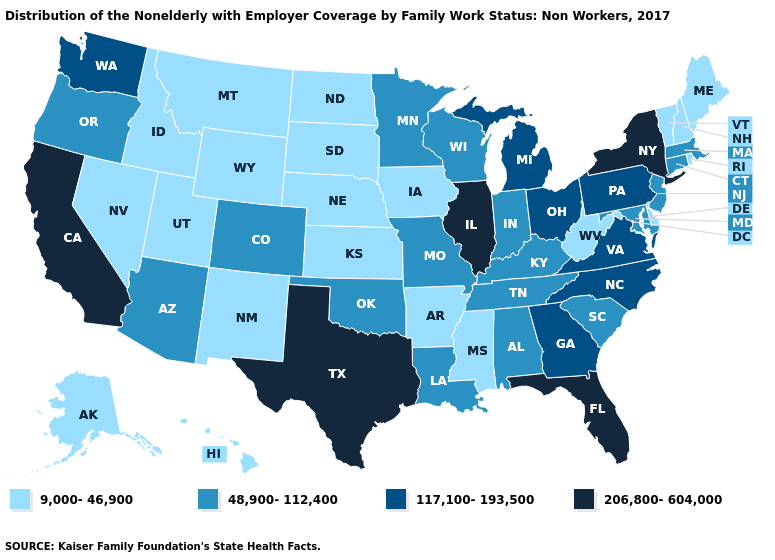Does Maine have the lowest value in the USA?
Short answer required. Yes. Name the states that have a value in the range 48,900-112,400?
Write a very short answer. Alabama, Arizona, Colorado, Connecticut, Indiana, Kentucky, Louisiana, Maryland, Massachusetts, Minnesota, Missouri, New Jersey, Oklahoma, Oregon, South Carolina, Tennessee, Wisconsin. Name the states that have a value in the range 9,000-46,900?
Give a very brief answer. Alaska, Arkansas, Delaware, Hawaii, Idaho, Iowa, Kansas, Maine, Mississippi, Montana, Nebraska, Nevada, New Hampshire, New Mexico, North Dakota, Rhode Island, South Dakota, Utah, Vermont, West Virginia, Wyoming. Name the states that have a value in the range 117,100-193,500?
Write a very short answer. Georgia, Michigan, North Carolina, Ohio, Pennsylvania, Virginia, Washington. Does Idaho have the lowest value in the USA?
Short answer required. Yes. Name the states that have a value in the range 117,100-193,500?
Keep it brief. Georgia, Michigan, North Carolina, Ohio, Pennsylvania, Virginia, Washington. Name the states that have a value in the range 206,800-604,000?
Quick response, please. California, Florida, Illinois, New York, Texas. Among the states that border Maine , which have the lowest value?
Give a very brief answer. New Hampshire. Is the legend a continuous bar?
Be succinct. No. What is the value of Georgia?
Give a very brief answer. 117,100-193,500. Does Minnesota have the same value as Arkansas?
Give a very brief answer. No. Among the states that border West Virginia , which have the highest value?
Short answer required. Ohio, Pennsylvania, Virginia. Does the first symbol in the legend represent the smallest category?
Be succinct. Yes. What is the lowest value in the USA?
Write a very short answer. 9,000-46,900. What is the highest value in the West ?
Be succinct. 206,800-604,000. 